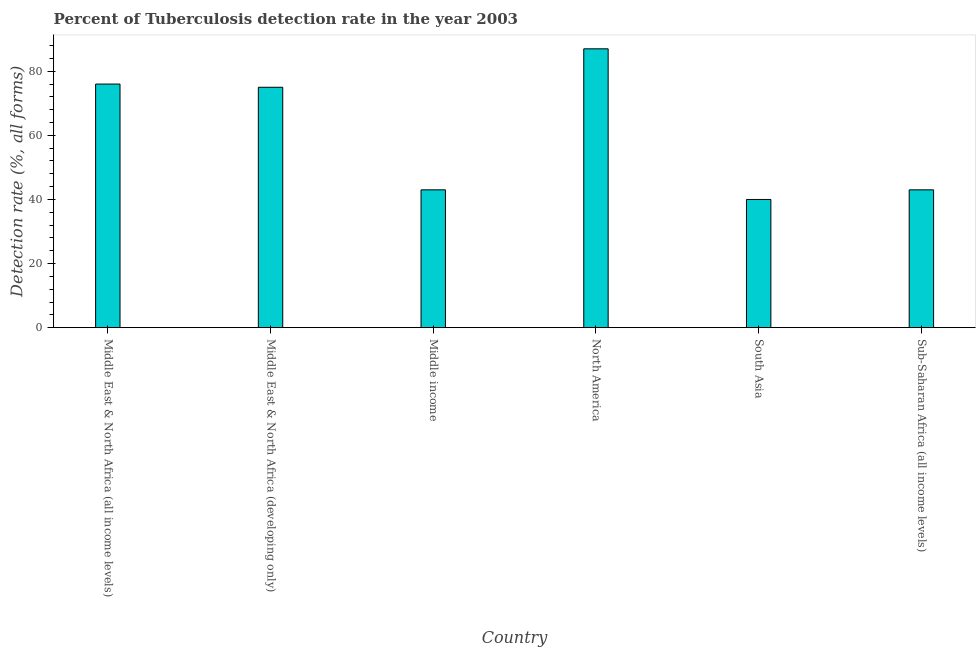Does the graph contain any zero values?
Your response must be concise. No. What is the title of the graph?
Make the answer very short. Percent of Tuberculosis detection rate in the year 2003. What is the label or title of the X-axis?
Your answer should be very brief. Country. What is the label or title of the Y-axis?
Your answer should be compact. Detection rate (%, all forms). In which country was the detection rate of tuberculosis minimum?
Provide a short and direct response. South Asia. What is the sum of the detection rate of tuberculosis?
Your answer should be very brief. 364. What is the difference between the detection rate of tuberculosis in Middle income and Sub-Saharan Africa (all income levels)?
Provide a succinct answer. 0. What is the average detection rate of tuberculosis per country?
Provide a short and direct response. 60.67. What is the ratio of the detection rate of tuberculosis in Middle East & North Africa (all income levels) to that in Middle East & North Africa (developing only)?
Your response must be concise. 1.01. Is the detection rate of tuberculosis in Middle East & North Africa (all income levels) less than that in North America?
Make the answer very short. Yes. Is the difference between the detection rate of tuberculosis in South Asia and Sub-Saharan Africa (all income levels) greater than the difference between any two countries?
Your answer should be very brief. No. Is the sum of the detection rate of tuberculosis in Middle East & North Africa (developing only) and South Asia greater than the maximum detection rate of tuberculosis across all countries?
Ensure brevity in your answer.  Yes. What is the difference between the highest and the lowest detection rate of tuberculosis?
Offer a very short reply. 47. In how many countries, is the detection rate of tuberculosis greater than the average detection rate of tuberculosis taken over all countries?
Your response must be concise. 3. How many bars are there?
Keep it short and to the point. 6. Are all the bars in the graph horizontal?
Offer a very short reply. No. How many countries are there in the graph?
Your answer should be very brief. 6. Are the values on the major ticks of Y-axis written in scientific E-notation?
Your answer should be compact. No. What is the Detection rate (%, all forms) in Middle East & North Africa (all income levels)?
Provide a succinct answer. 76. What is the Detection rate (%, all forms) in Sub-Saharan Africa (all income levels)?
Give a very brief answer. 43. What is the difference between the Detection rate (%, all forms) in Middle East & North Africa (all income levels) and Middle East & North Africa (developing only)?
Provide a short and direct response. 1. What is the difference between the Detection rate (%, all forms) in Middle East & North Africa (all income levels) and Middle income?
Offer a terse response. 33. What is the difference between the Detection rate (%, all forms) in Middle income and North America?
Your response must be concise. -44. What is the difference between the Detection rate (%, all forms) in Middle income and South Asia?
Your answer should be compact. 3. What is the difference between the Detection rate (%, all forms) in Middle income and Sub-Saharan Africa (all income levels)?
Give a very brief answer. 0. What is the difference between the Detection rate (%, all forms) in South Asia and Sub-Saharan Africa (all income levels)?
Provide a short and direct response. -3. What is the ratio of the Detection rate (%, all forms) in Middle East & North Africa (all income levels) to that in Middle East & North Africa (developing only)?
Give a very brief answer. 1.01. What is the ratio of the Detection rate (%, all forms) in Middle East & North Africa (all income levels) to that in Middle income?
Ensure brevity in your answer.  1.77. What is the ratio of the Detection rate (%, all forms) in Middle East & North Africa (all income levels) to that in North America?
Provide a short and direct response. 0.87. What is the ratio of the Detection rate (%, all forms) in Middle East & North Africa (all income levels) to that in South Asia?
Provide a succinct answer. 1.9. What is the ratio of the Detection rate (%, all forms) in Middle East & North Africa (all income levels) to that in Sub-Saharan Africa (all income levels)?
Offer a terse response. 1.77. What is the ratio of the Detection rate (%, all forms) in Middle East & North Africa (developing only) to that in Middle income?
Provide a succinct answer. 1.74. What is the ratio of the Detection rate (%, all forms) in Middle East & North Africa (developing only) to that in North America?
Your response must be concise. 0.86. What is the ratio of the Detection rate (%, all forms) in Middle East & North Africa (developing only) to that in South Asia?
Give a very brief answer. 1.88. What is the ratio of the Detection rate (%, all forms) in Middle East & North Africa (developing only) to that in Sub-Saharan Africa (all income levels)?
Offer a very short reply. 1.74. What is the ratio of the Detection rate (%, all forms) in Middle income to that in North America?
Provide a short and direct response. 0.49. What is the ratio of the Detection rate (%, all forms) in Middle income to that in South Asia?
Offer a very short reply. 1.07. What is the ratio of the Detection rate (%, all forms) in Middle income to that in Sub-Saharan Africa (all income levels)?
Your answer should be very brief. 1. What is the ratio of the Detection rate (%, all forms) in North America to that in South Asia?
Make the answer very short. 2.17. What is the ratio of the Detection rate (%, all forms) in North America to that in Sub-Saharan Africa (all income levels)?
Give a very brief answer. 2.02. What is the ratio of the Detection rate (%, all forms) in South Asia to that in Sub-Saharan Africa (all income levels)?
Offer a terse response. 0.93. 